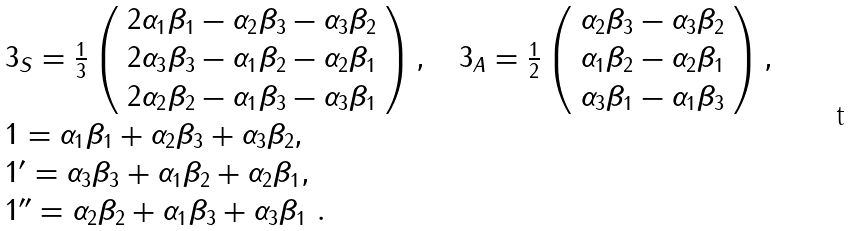Convert formula to latex. <formula><loc_0><loc_0><loc_500><loc_500>\begin{array} { l } 3 _ { S } = \frac { 1 } { 3 } \left ( \begin{array} { c } 2 \alpha _ { 1 } \beta _ { 1 } - \alpha _ { 2 } \beta _ { 3 } - \alpha _ { 3 } \beta _ { 2 } \\ 2 \alpha _ { 3 } \beta _ { 3 } - \alpha _ { 1 } \beta _ { 2 } - \alpha _ { 2 } \beta _ { 1 } \\ 2 \alpha _ { 2 } \beta _ { 2 } - \alpha _ { 1 } \beta _ { 3 } - \alpha _ { 3 } \beta _ { 1 } \\ \end{array} \right ) , \quad 3 _ { A } = \frac { 1 } { 2 } \left ( \begin{array} { c } \alpha _ { 2 } \beta _ { 3 } - \alpha _ { 3 } \beta _ { 2 } \\ \alpha _ { 1 } \beta _ { 2 } - \alpha _ { 2 } \beta _ { 1 } \\ \alpha _ { 3 } \beta _ { 1 } - \alpha _ { 1 } \beta _ { 3 } \\ \end{array} \right ) , \\ 1 = \alpha _ { 1 } \beta _ { 1 } + \alpha _ { 2 } \beta _ { 3 } + \alpha _ { 3 } \beta _ { 2 } , \\ 1 ^ { \prime } = \alpha _ { 3 } \beta _ { 3 } + \alpha _ { 1 } \beta _ { 2 } + \alpha _ { 2 } \beta _ { 1 } , \\ 1 ^ { \prime \prime } = \alpha _ { 2 } \beta _ { 2 } + \alpha _ { 1 } \beta _ { 3 } + \alpha _ { 3 } \beta _ { 1 } \ . \\ \end{array}</formula> 